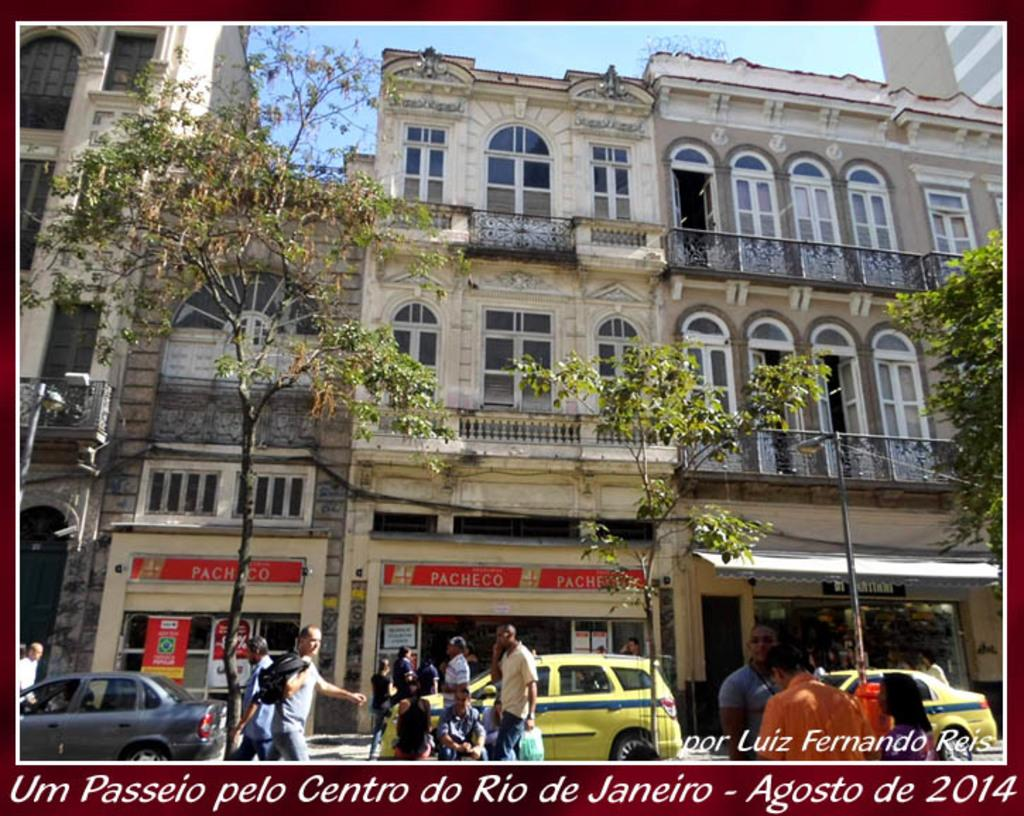Provide a one-sentence caption for the provided image. A photograph of some buildings in Rio de Janeiro was taken in 2014. 